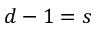Convert formula to latex. <formula><loc_0><loc_0><loc_500><loc_500>d - 1 = s</formula> 